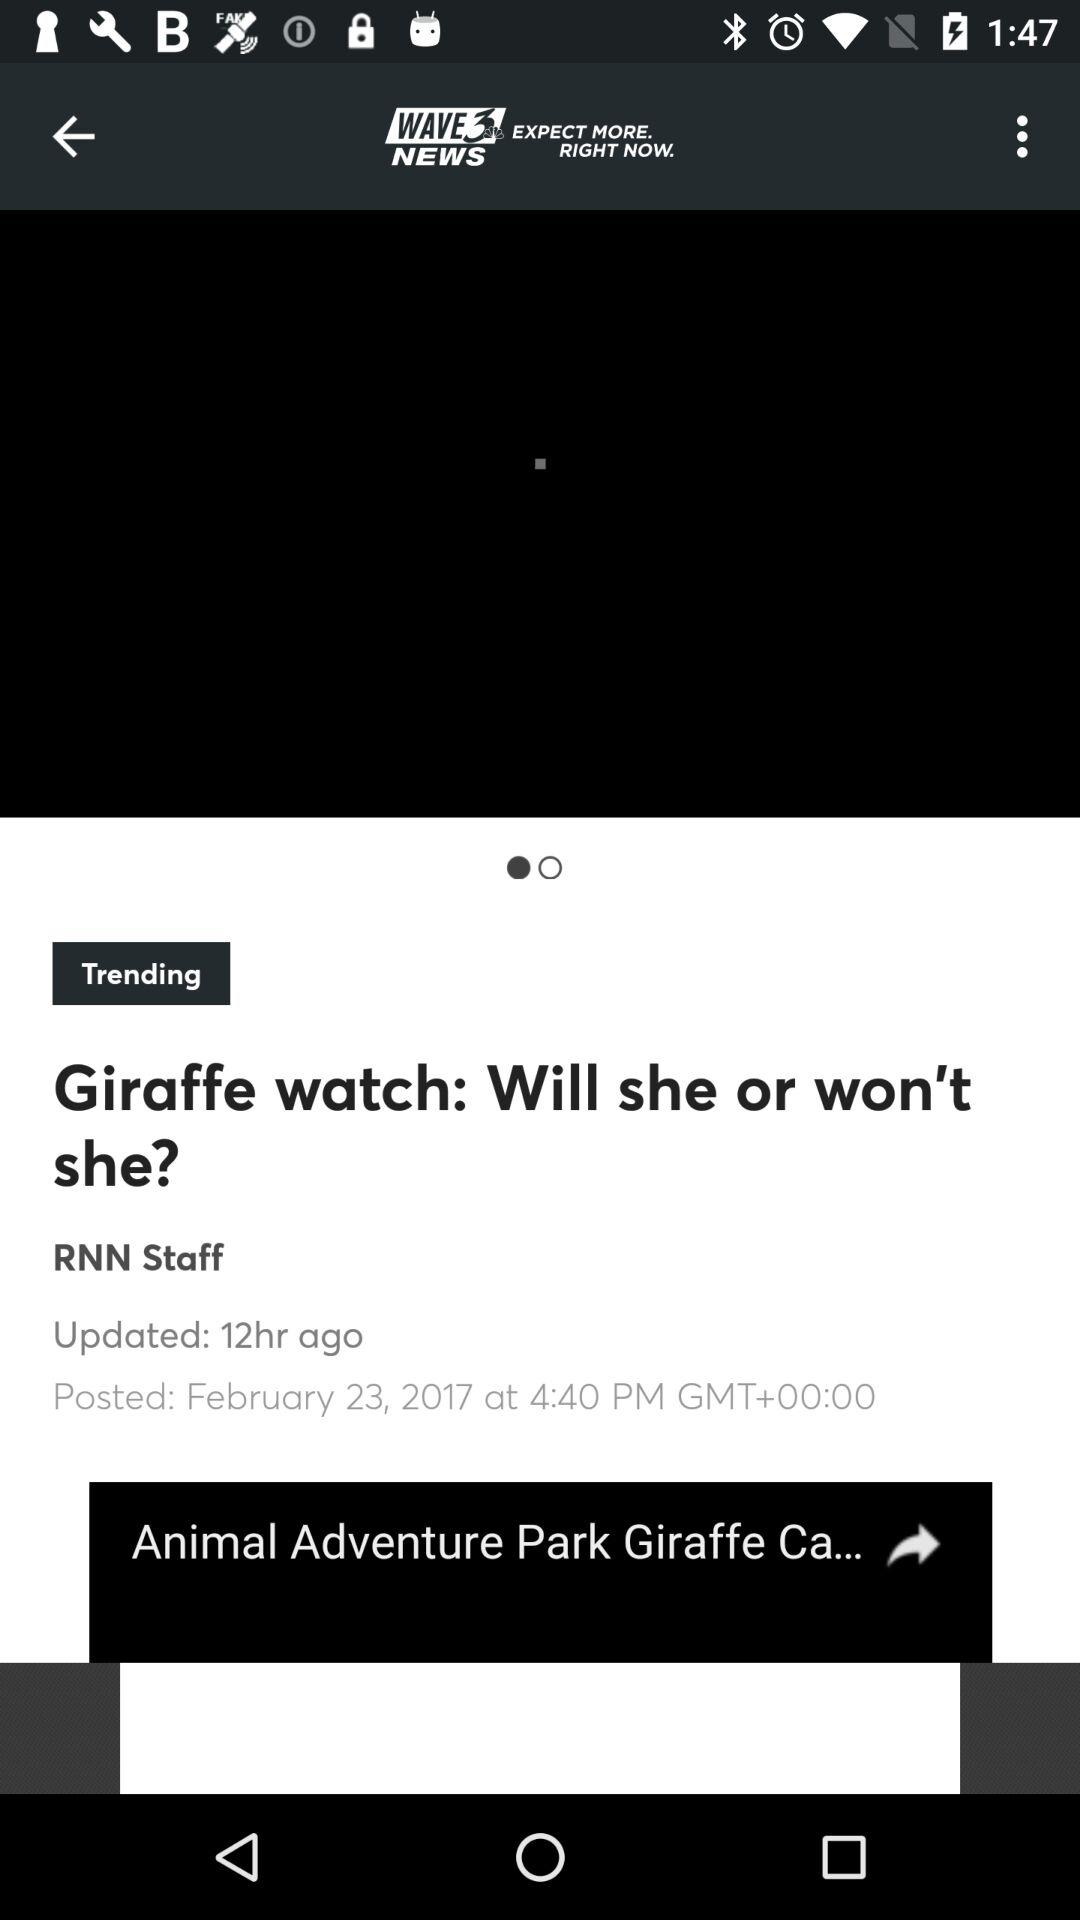On what date was the article posted? The article was posted on February 23, 2017. 